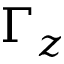<formula> <loc_0><loc_0><loc_500><loc_500>\Gamma _ { z }</formula> 